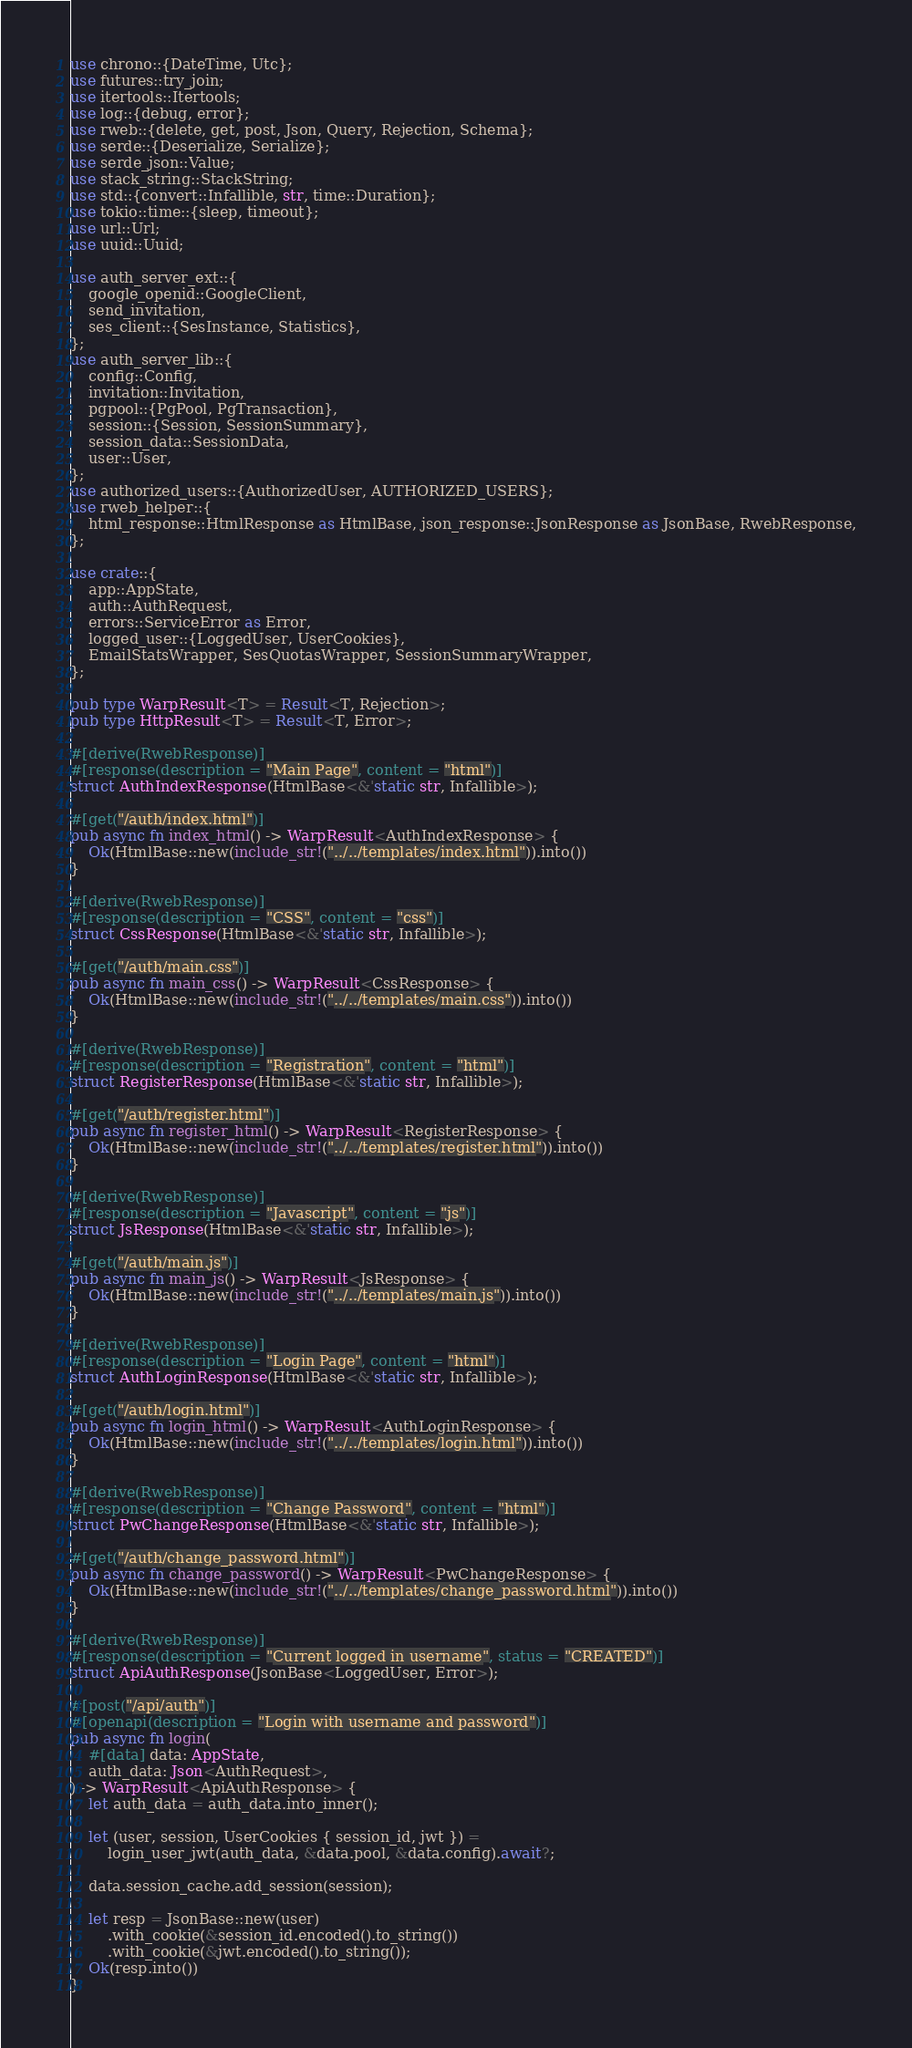<code> <loc_0><loc_0><loc_500><loc_500><_Rust_>use chrono::{DateTime, Utc};
use futures::try_join;
use itertools::Itertools;
use log::{debug, error};
use rweb::{delete, get, post, Json, Query, Rejection, Schema};
use serde::{Deserialize, Serialize};
use serde_json::Value;
use stack_string::StackString;
use std::{convert::Infallible, str, time::Duration};
use tokio::time::{sleep, timeout};
use url::Url;
use uuid::Uuid;

use auth_server_ext::{
    google_openid::GoogleClient,
    send_invitation,
    ses_client::{SesInstance, Statistics},
};
use auth_server_lib::{
    config::Config,
    invitation::Invitation,
    pgpool::{PgPool, PgTransaction},
    session::{Session, SessionSummary},
    session_data::SessionData,
    user::User,
};
use authorized_users::{AuthorizedUser, AUTHORIZED_USERS};
use rweb_helper::{
    html_response::HtmlResponse as HtmlBase, json_response::JsonResponse as JsonBase, RwebResponse,
};

use crate::{
    app::AppState,
    auth::AuthRequest,
    errors::ServiceError as Error,
    logged_user::{LoggedUser, UserCookies},
    EmailStatsWrapper, SesQuotasWrapper, SessionSummaryWrapper,
};

pub type WarpResult<T> = Result<T, Rejection>;
pub type HttpResult<T> = Result<T, Error>;

#[derive(RwebResponse)]
#[response(description = "Main Page", content = "html")]
struct AuthIndexResponse(HtmlBase<&'static str, Infallible>);

#[get("/auth/index.html")]
pub async fn index_html() -> WarpResult<AuthIndexResponse> {
    Ok(HtmlBase::new(include_str!("../../templates/index.html")).into())
}

#[derive(RwebResponse)]
#[response(description = "CSS", content = "css")]
struct CssResponse(HtmlBase<&'static str, Infallible>);

#[get("/auth/main.css")]
pub async fn main_css() -> WarpResult<CssResponse> {
    Ok(HtmlBase::new(include_str!("../../templates/main.css")).into())
}

#[derive(RwebResponse)]
#[response(description = "Registration", content = "html")]
struct RegisterResponse(HtmlBase<&'static str, Infallible>);

#[get("/auth/register.html")]
pub async fn register_html() -> WarpResult<RegisterResponse> {
    Ok(HtmlBase::new(include_str!("../../templates/register.html")).into())
}

#[derive(RwebResponse)]
#[response(description = "Javascript", content = "js")]
struct JsResponse(HtmlBase<&'static str, Infallible>);

#[get("/auth/main.js")]
pub async fn main_js() -> WarpResult<JsResponse> {
    Ok(HtmlBase::new(include_str!("../../templates/main.js")).into())
}

#[derive(RwebResponse)]
#[response(description = "Login Page", content = "html")]
struct AuthLoginResponse(HtmlBase<&'static str, Infallible>);

#[get("/auth/login.html")]
pub async fn login_html() -> WarpResult<AuthLoginResponse> {
    Ok(HtmlBase::new(include_str!("../../templates/login.html")).into())
}

#[derive(RwebResponse)]
#[response(description = "Change Password", content = "html")]
struct PwChangeResponse(HtmlBase<&'static str, Infallible>);

#[get("/auth/change_password.html")]
pub async fn change_password() -> WarpResult<PwChangeResponse> {
    Ok(HtmlBase::new(include_str!("../../templates/change_password.html")).into())
}

#[derive(RwebResponse)]
#[response(description = "Current logged in username", status = "CREATED")]
struct ApiAuthResponse(JsonBase<LoggedUser, Error>);

#[post("/api/auth")]
#[openapi(description = "Login with username and password")]
pub async fn login(
    #[data] data: AppState,
    auth_data: Json<AuthRequest>,
) -> WarpResult<ApiAuthResponse> {
    let auth_data = auth_data.into_inner();

    let (user, session, UserCookies { session_id, jwt }) =
        login_user_jwt(auth_data, &data.pool, &data.config).await?;

    data.session_cache.add_session(session);

    let resp = JsonBase::new(user)
        .with_cookie(&session_id.encoded().to_string())
        .with_cookie(&jwt.encoded().to_string());
    Ok(resp.into())
}
</code> 